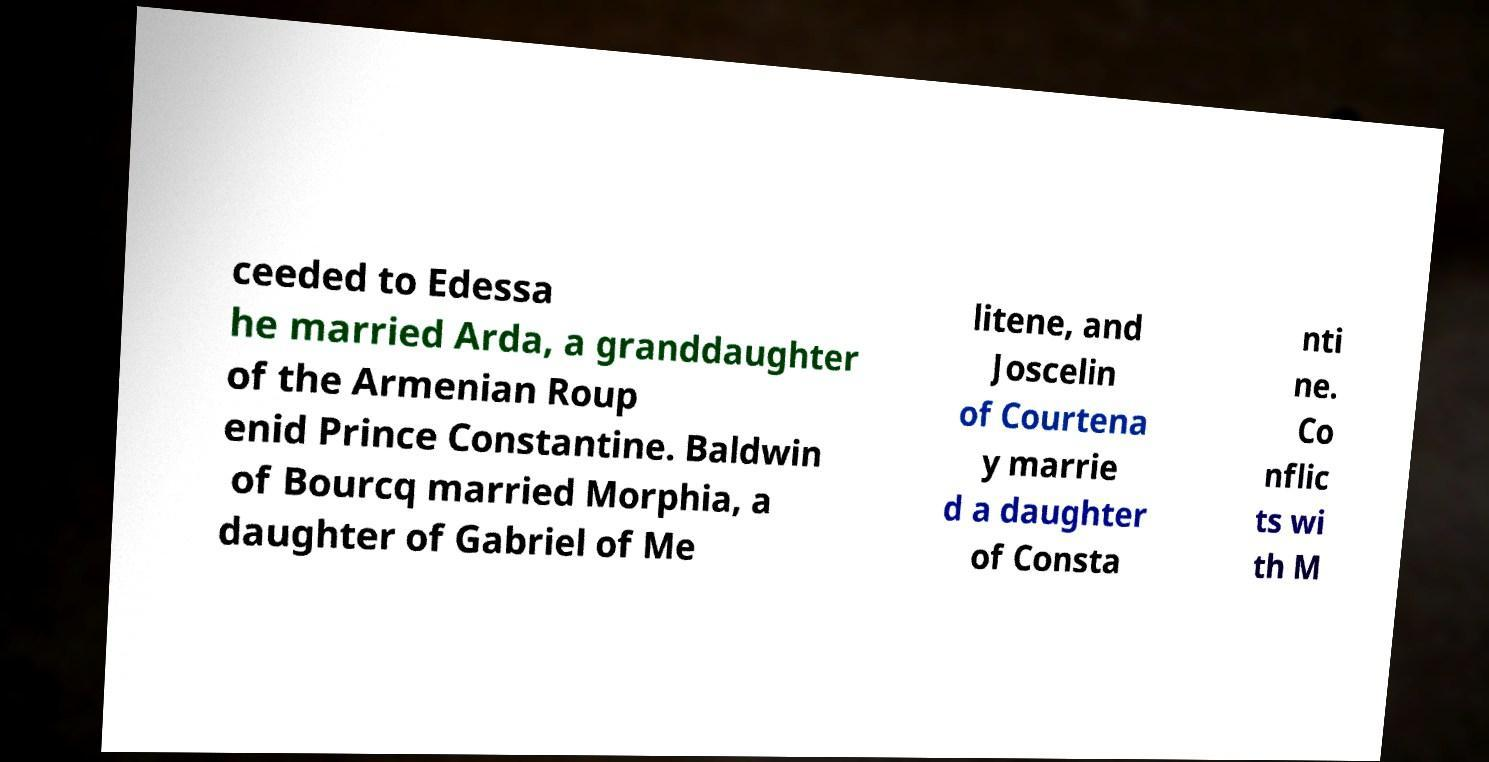Can you read and provide the text displayed in the image?This photo seems to have some interesting text. Can you extract and type it out for me? ceeded to Edessa he married Arda, a granddaughter of the Armenian Roup enid Prince Constantine. Baldwin of Bourcq married Morphia, a daughter of Gabriel of Me litene, and Joscelin of Courtena y marrie d a daughter of Consta nti ne. Co nflic ts wi th M 